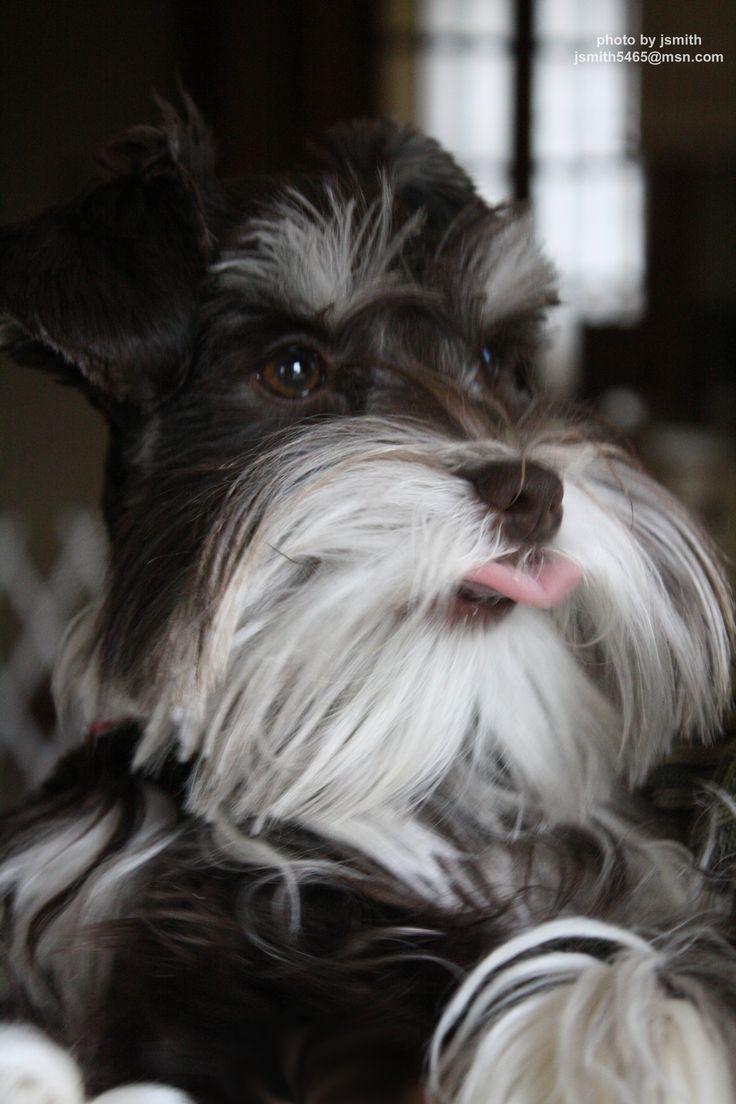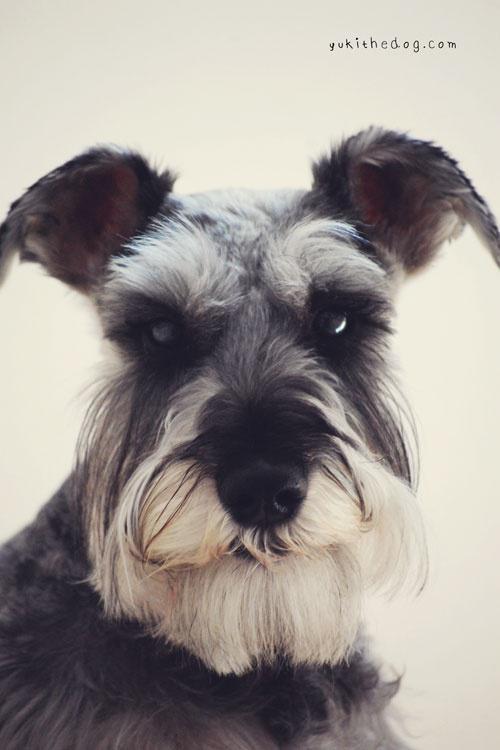The first image is the image on the left, the second image is the image on the right. Examine the images to the left and right. Is the description "The dog in at least one of the images has its tongue hanging out." accurate? Answer yes or no. Yes. The first image is the image on the left, the second image is the image on the right. Assess this claim about the two images: "Each image shows a single schnauzer that is not in costume, and at least one image features a dog with its tongue sticking out.". Correct or not? Answer yes or no. Yes. 